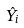Convert formula to latex. <formula><loc_0><loc_0><loc_500><loc_500>\hat { Y } _ { i }</formula> 